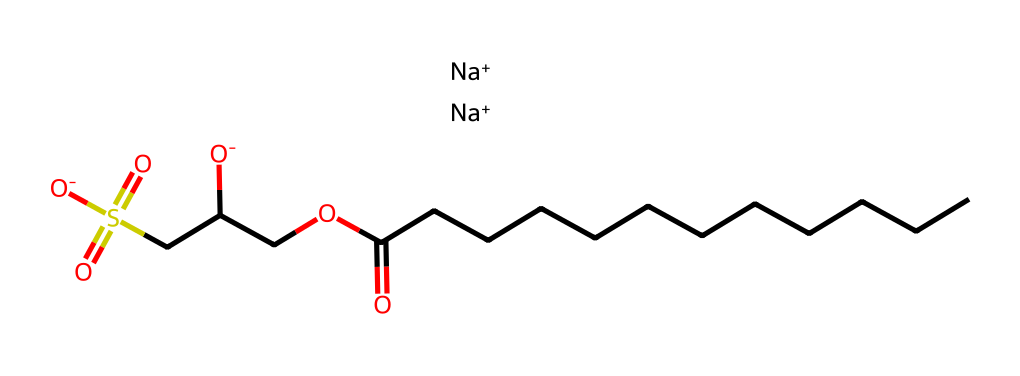What is the main functional group present in sodium cocoyl isethionate? The structure contains a carboxylate group (-COO-) which is indicative of its function as a surfactant. This group is active in various cleaning and emulsifying properties.
Answer: carboxylate How many carbon atoms are in sodium cocoyl isethionate? By analyzing the carbon chain, there are 12 carbon atoms in the long hydrocarbon tail and 2 additional carbons from the isethionate portion, totaling 14.
Answer: 14 What is the net charge on sodium cocoyl isethionate? The chemical contains two sodium cations that balance the negative charges from the two carboxylate groups, resulting in an overall neutral charge.
Answer: zero Which component in the structure contributes to its surfactant properties? The long hydrophobic carbon chain (hydrocarbon tail) and the hydrophilic isethionate part form the amphiphilic characteristic which is crucial for surfactant behavior.
Answer: hydrocarbon tail What is the significance of the sulfonate group in this compound? The sulfonate group enhances the solubility of the compound in water and improves its ability to reduce surface tension, thus optimizing its cleaning effectiveness.
Answer: enhances solubility 